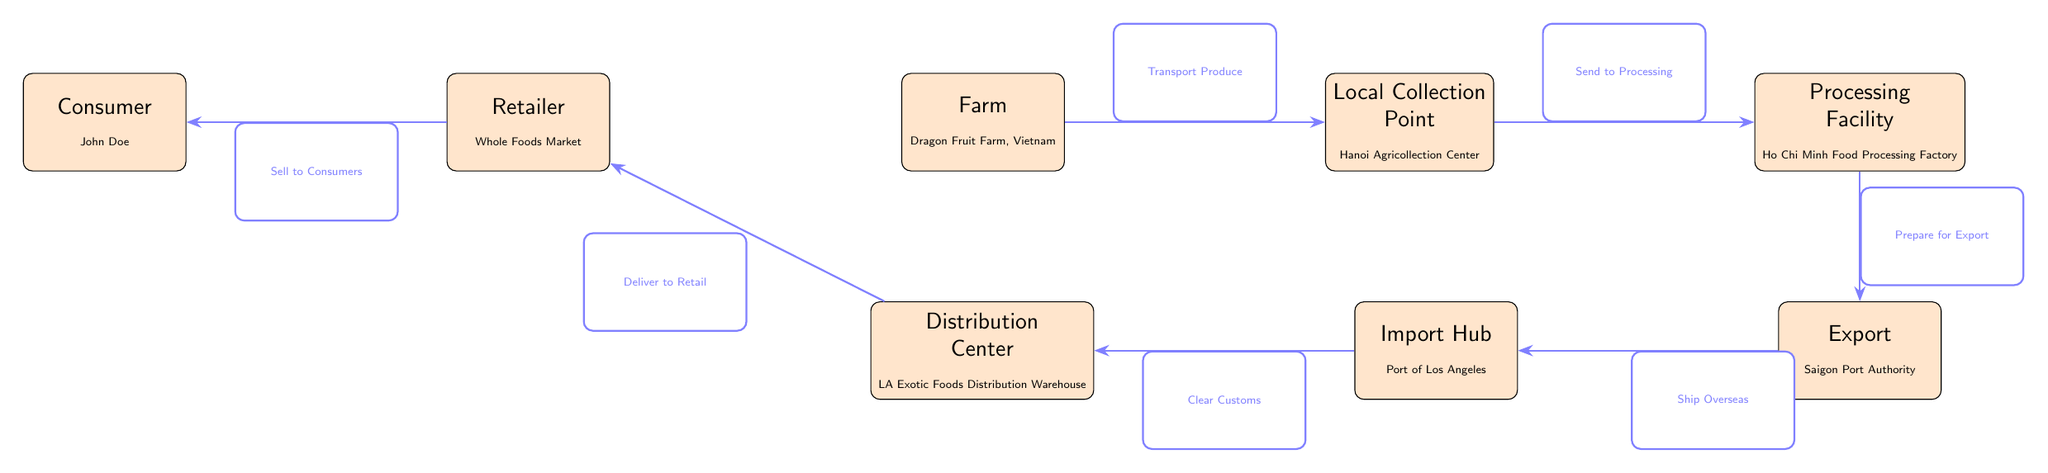What is the first step in the food chain? The first node in the diagram is the farm, which is labeled as "Farm" and specifies "Dragon Fruit Farm, Vietnam". Therefore, the first step in the food chain is the farm.
Answer: Farm How many nodes are in the food chain? The diagram contains a total of 7 nodes, which are Farm, Local Collection Point, Processing Facility, Export, Import Hub, Distribution Center, Retailer, and Consumer.
Answer: 7 What is the last step in the food chain? The last node in the diagram is the consumer, specifically labeled as "Consumer" with the name "John Doe". Thus, the last step in the food chain is the consumer.
Answer: Consumer What is the relationship between processing facility and export? The processing facility sends its products to the export node. The arrow labeled "Prepare for Export" connects Processing Facility to Export, indicating the processing step prepares the goods for export.
Answer: Prepare for Export Which node is connected directly to the retailer? The retailer is directly connected to the distribution center, as there is an arrow labeled "Deliver to Retail" pointing from Distribution Center to Retailer.
Answer: Distribution Center What is shipped overseas from the export node? The goods, after being processed, are shipped overseas as indicated by the arrow labeled "Ship Overseas" pointing from Export to Import Hub.
Answer: Produce How does the local collection point relate to the farm? The local collection point receives produce from the farm, as shown by the arrow labeled "Transport Produce" that goes from the farm to the local collection point.
Answer: Transport Produce How many export steps are present in the chain? There is only one export step in the diagram, as indicated by the single node for Export connected to the Processing Facility, with an arrow pointing from Processing to Export.
Answer: 1 